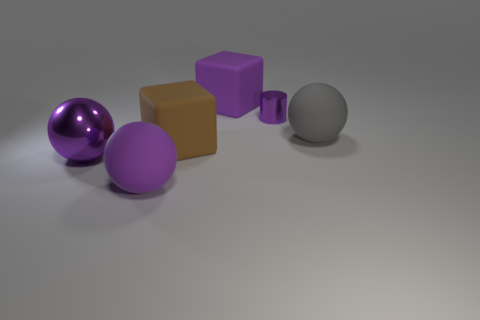Subtract all big purple shiny balls. How many balls are left? 2 Add 2 brown matte balls. How many objects exist? 8 Subtract all blue blocks. How many purple balls are left? 2 Subtract all brown blocks. How many blocks are left? 1 Subtract all cylinders. How many objects are left? 5 Add 5 large spheres. How many large spheres are left? 8 Add 6 large spheres. How many large spheres exist? 9 Subtract 1 purple spheres. How many objects are left? 5 Subtract 1 blocks. How many blocks are left? 1 Subtract all yellow cylinders. Subtract all blue blocks. How many cylinders are left? 1 